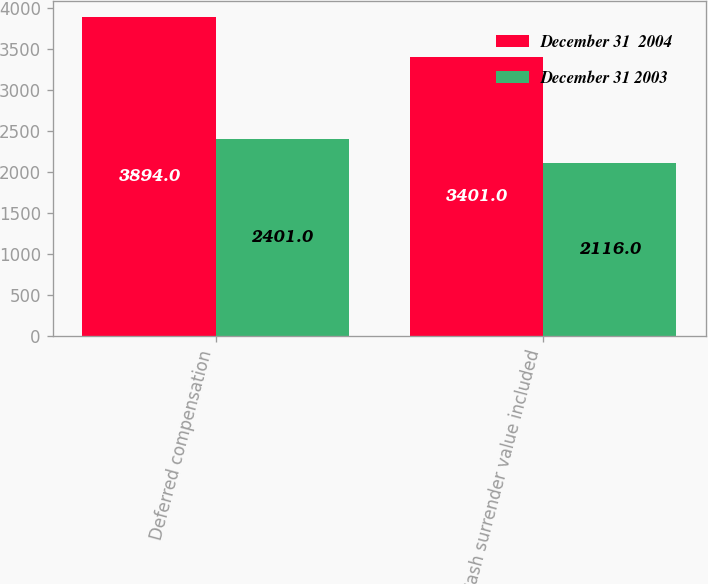Convert chart. <chart><loc_0><loc_0><loc_500><loc_500><stacked_bar_chart><ecel><fcel>Deferred compensation<fcel>Cash surrender value included<nl><fcel>December 31  2004<fcel>3894<fcel>3401<nl><fcel>December 31 2003<fcel>2401<fcel>2116<nl></chart> 